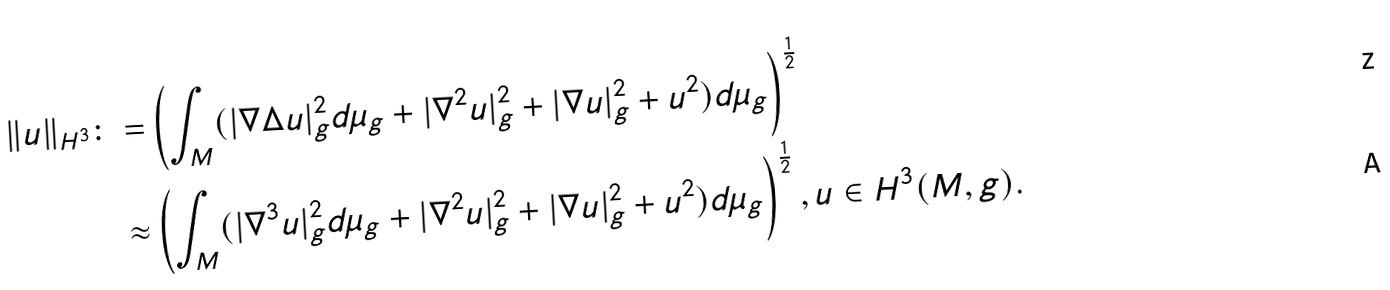Convert formula to latex. <formula><loc_0><loc_0><loc_500><loc_500>\| u \| _ { H ^ { 3 } } \colon = & \left ( \int _ { M } ( | \nabla \Delta u | _ { g } ^ { 2 } d \mu _ { g } + | \nabla ^ { 2 } u | _ { g } ^ { 2 } + | \nabla u | _ { g } ^ { 2 } + u ^ { 2 } ) d \mu _ { g } \right ) ^ { \frac { 1 } { 2 } } \\ \approx & \left ( \int _ { M } ( | \nabla ^ { 3 } u | _ { g } ^ { 2 } d \mu _ { g } + | \nabla ^ { 2 } u | _ { g } ^ { 2 } + | \nabla u | _ { g } ^ { 2 } + u ^ { 2 } ) d \mu _ { g } \right ) ^ { \frac { 1 } { 2 } } , u \in H ^ { 3 } ( M , g ) .</formula> 